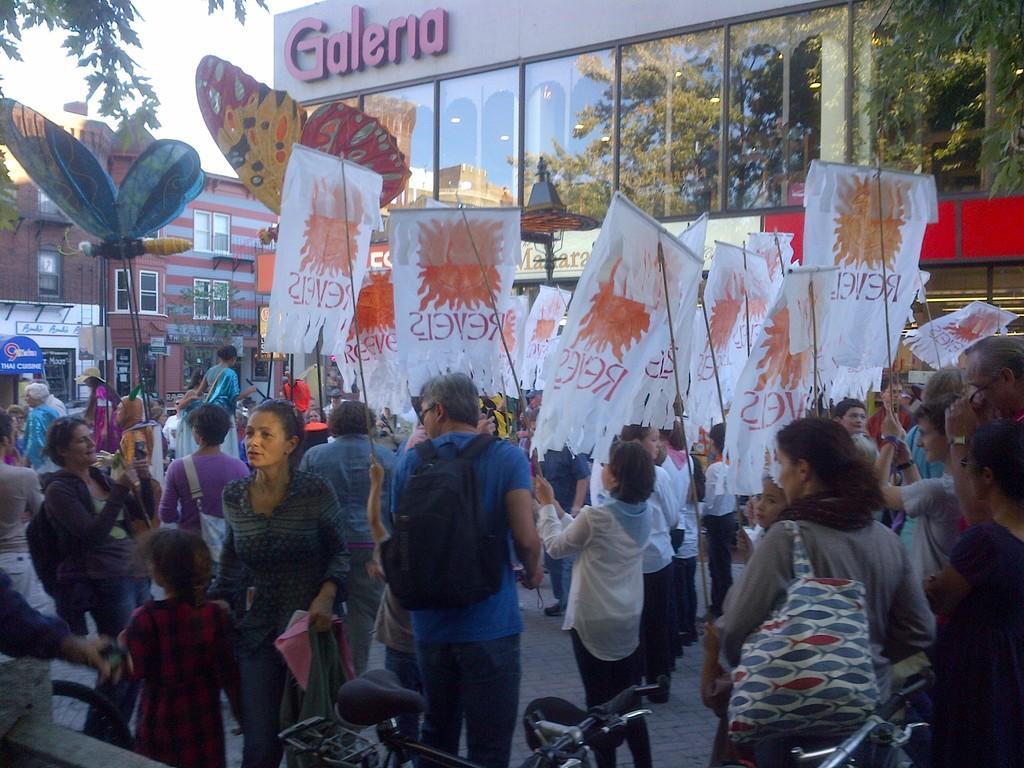Could you give a brief overview of what you see in this image? In this image we can see a group of persons. Among them there are few people holding banners. Behind the persons we can see the buildings. On the building glass we can see the reflection of the trees. At the bottom we can see the bicycles. In the top left, we can see the leaves and the sky. 